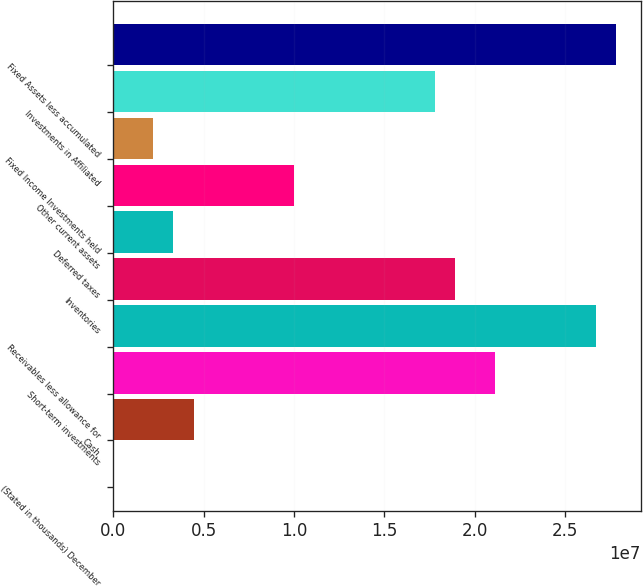Convert chart. <chart><loc_0><loc_0><loc_500><loc_500><bar_chart><fcel>(Stated in thousands) December<fcel>Cash<fcel>Short-term investments<fcel>Receivables less allowance for<fcel>Inventories<fcel>Deferred taxes<fcel>Other current assets<fcel>Fixed Income Investments held<fcel>Investments in Affiliated<fcel>Fixed Assets less accumulated<nl><fcel>2006<fcel>4.4486e+06<fcel>2.11233e+07<fcel>2.66815e+07<fcel>1.89e+07<fcel>3.33695e+06<fcel>1.00068e+07<fcel>2.2253e+06<fcel>1.77884e+07<fcel>2.77932e+07<nl></chart> 